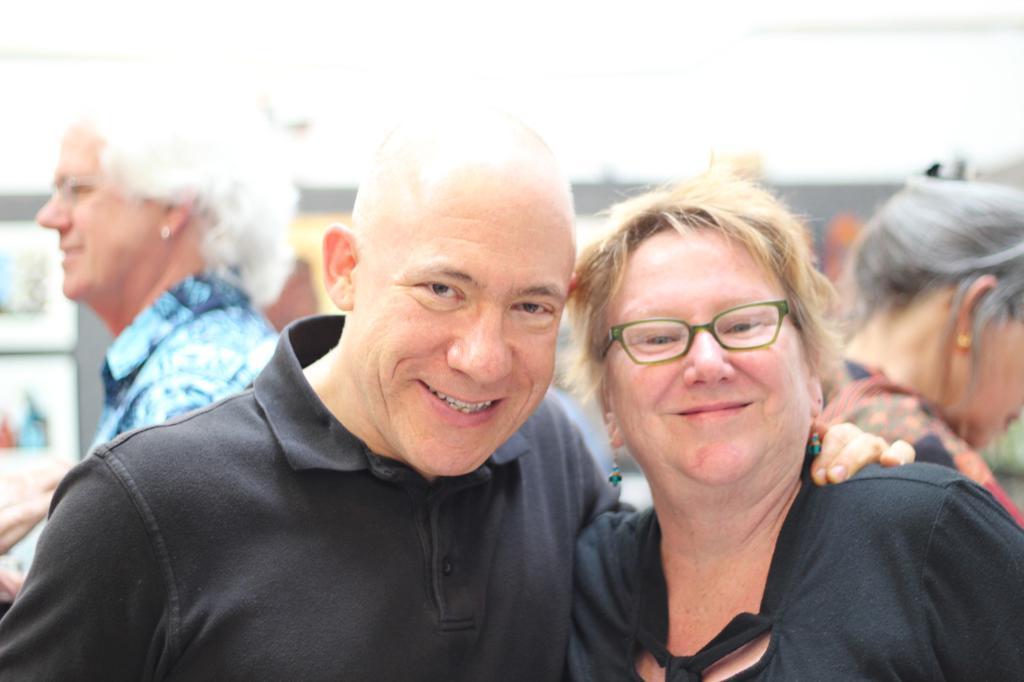Can you describe this image briefly? In this image we can see few people. Lady on the right side is wearing specs. In the background it is blur. 